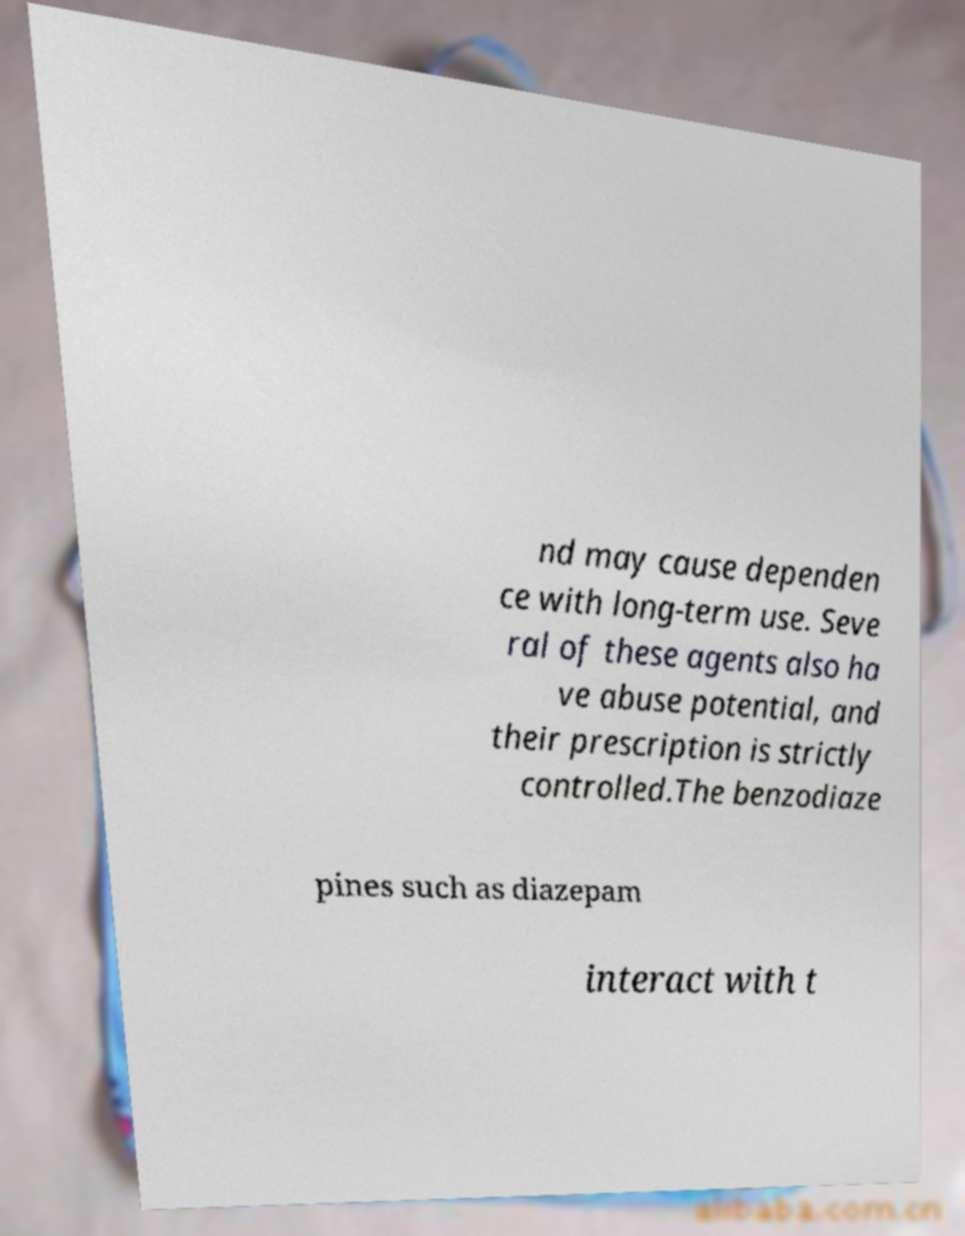Could you extract and type out the text from this image? nd may cause dependen ce with long-term use. Seve ral of these agents also ha ve abuse potential, and their prescription is strictly controlled.The benzodiaze pines such as diazepam interact with t 